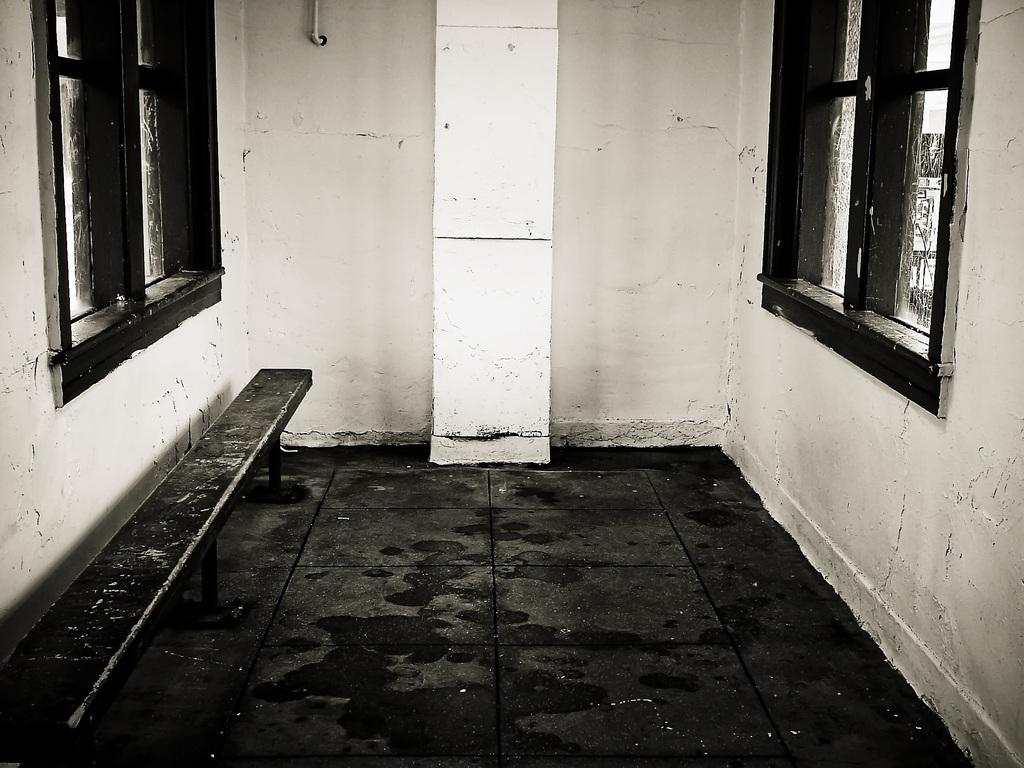What type of bench is in the image? There is a metal bench in the image. What can be seen beneath the bench? The ground is visible in the image. What is located behind the bench? There is a wall with windows in the image. What objects are near the wall? There are objects visible on or near the wall. How many shoes are hanging from the wall in the image? There are no shoes hanging from the wall in the image. 